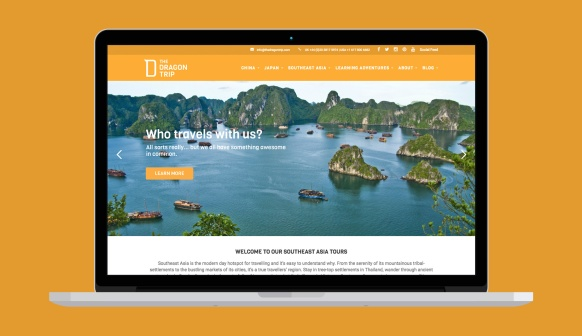What are the key elements in this picture? The image showcases the homepage of a travel company's website named Dragon Trip. The design is sleek and straightforward, featuring an attention-grabbing orange header with the company's logo on the left and a set of navigation links. The website's focal point is a stunning seascape image of various islands spread across a tranquil sea, with boats floating peacefully. Superimposed on this image is an engaging question, 'Who travels with us?', encouraging visitors to explore the company's diverse clientele. Below the seascape, a section introduces visitors to the company's Southeast Asia tours, hinting at their offerings in this region. The overall layout is user-friendly, aiming to attract and retain potential travelers through its visually appealing and intuitive design. 